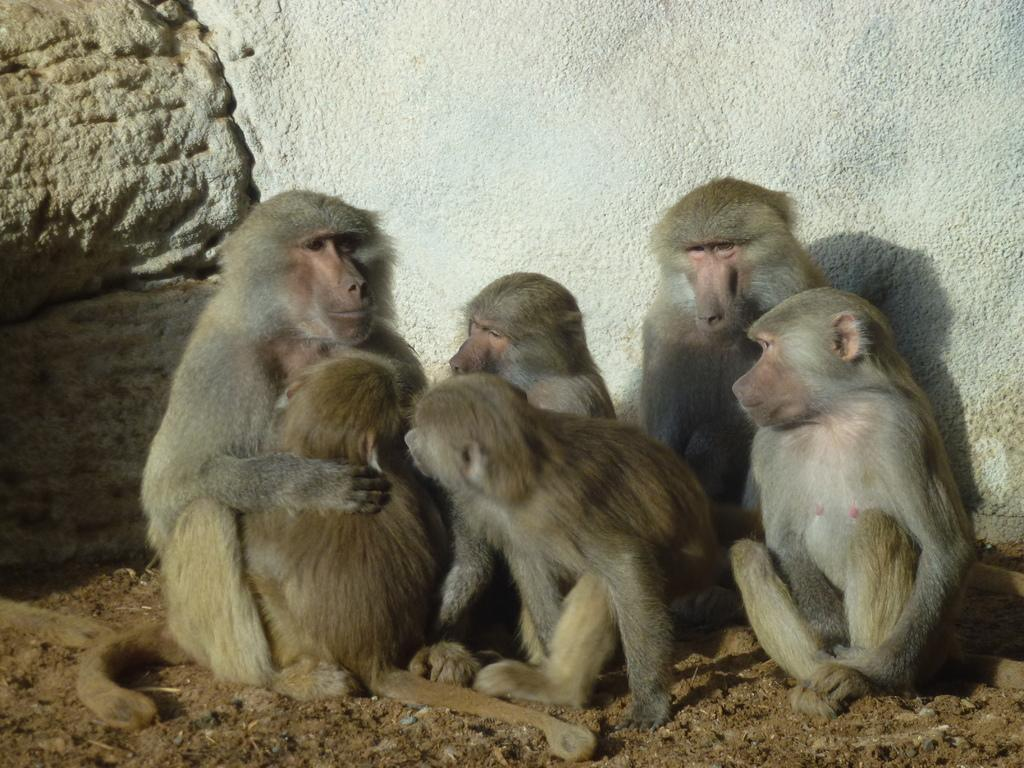What animals are present in the image? There are monkeys in the image. Where are the monkeys sitting? The monkeys are sitting on the sand. What can be seen in the background of the image? There is a wall visible in the background of the image. What type of terrain is visible in the image? There is sand in the image. What type of box can be seen in the image? There is no box present in the image. What kind of stone is being used by the monkeys in the image? There are no stones being used by the monkeys in the image. 